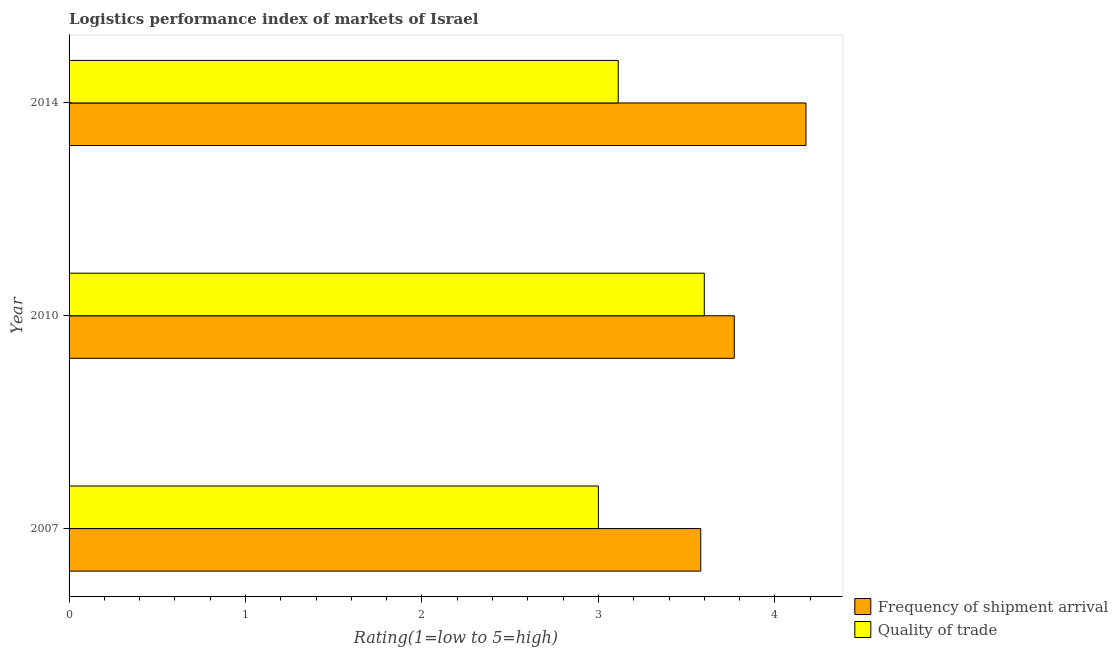How many different coloured bars are there?
Your response must be concise. 2. Are the number of bars per tick equal to the number of legend labels?
Your response must be concise. Yes. Are the number of bars on each tick of the Y-axis equal?
Make the answer very short. Yes. How many bars are there on the 3rd tick from the bottom?
Ensure brevity in your answer.  2. Across all years, what is the minimum lpi of frequency of shipment arrival?
Your answer should be compact. 3.58. In which year was the lpi quality of trade maximum?
Make the answer very short. 2010. What is the total lpi quality of trade in the graph?
Offer a very short reply. 9.71. What is the difference between the lpi of frequency of shipment arrival in 2007 and that in 2014?
Keep it short and to the point. -0.6. What is the difference between the lpi quality of trade in 2010 and the lpi of frequency of shipment arrival in 2007?
Provide a succinct answer. 0.02. What is the average lpi of frequency of shipment arrival per year?
Offer a terse response. 3.84. In the year 2010, what is the difference between the lpi quality of trade and lpi of frequency of shipment arrival?
Ensure brevity in your answer.  -0.17. What is the ratio of the lpi quality of trade in 2010 to that in 2014?
Provide a short and direct response. 1.16. Is the lpi of frequency of shipment arrival in 2007 less than that in 2010?
Your answer should be very brief. Yes. What is the difference between the highest and the second highest lpi of frequency of shipment arrival?
Offer a very short reply. 0.41. In how many years, is the lpi of frequency of shipment arrival greater than the average lpi of frequency of shipment arrival taken over all years?
Your answer should be compact. 1. Is the sum of the lpi of frequency of shipment arrival in 2007 and 2014 greater than the maximum lpi quality of trade across all years?
Ensure brevity in your answer.  Yes. What does the 2nd bar from the top in 2010 represents?
Make the answer very short. Frequency of shipment arrival. What does the 1st bar from the bottom in 2010 represents?
Ensure brevity in your answer.  Frequency of shipment arrival. How many bars are there?
Your answer should be compact. 6. How many years are there in the graph?
Offer a very short reply. 3. What is the difference between two consecutive major ticks on the X-axis?
Give a very brief answer. 1. Are the values on the major ticks of X-axis written in scientific E-notation?
Your response must be concise. No. Does the graph contain grids?
Ensure brevity in your answer.  No. Where does the legend appear in the graph?
Provide a short and direct response. Bottom right. What is the title of the graph?
Offer a terse response. Logistics performance index of markets of Israel. What is the label or title of the X-axis?
Offer a terse response. Rating(1=low to 5=high). What is the label or title of the Y-axis?
Provide a short and direct response. Year. What is the Rating(1=low to 5=high) of Frequency of shipment arrival in 2007?
Ensure brevity in your answer.  3.58. What is the Rating(1=low to 5=high) in Frequency of shipment arrival in 2010?
Keep it short and to the point. 3.77. What is the Rating(1=low to 5=high) of Quality of trade in 2010?
Your answer should be very brief. 3.6. What is the Rating(1=low to 5=high) of Frequency of shipment arrival in 2014?
Provide a short and direct response. 4.18. What is the Rating(1=low to 5=high) of Quality of trade in 2014?
Provide a succinct answer. 3.11. Across all years, what is the maximum Rating(1=low to 5=high) in Frequency of shipment arrival?
Your answer should be very brief. 4.18. Across all years, what is the minimum Rating(1=low to 5=high) in Frequency of shipment arrival?
Provide a succinct answer. 3.58. Across all years, what is the minimum Rating(1=low to 5=high) in Quality of trade?
Ensure brevity in your answer.  3. What is the total Rating(1=low to 5=high) of Frequency of shipment arrival in the graph?
Your answer should be very brief. 11.53. What is the total Rating(1=low to 5=high) of Quality of trade in the graph?
Make the answer very short. 9.71. What is the difference between the Rating(1=low to 5=high) of Frequency of shipment arrival in 2007 and that in 2010?
Your answer should be very brief. -0.19. What is the difference between the Rating(1=low to 5=high) of Frequency of shipment arrival in 2007 and that in 2014?
Ensure brevity in your answer.  -0.6. What is the difference between the Rating(1=low to 5=high) in Quality of trade in 2007 and that in 2014?
Your answer should be compact. -0.11. What is the difference between the Rating(1=low to 5=high) of Frequency of shipment arrival in 2010 and that in 2014?
Keep it short and to the point. -0.41. What is the difference between the Rating(1=low to 5=high) of Quality of trade in 2010 and that in 2014?
Make the answer very short. 0.49. What is the difference between the Rating(1=low to 5=high) in Frequency of shipment arrival in 2007 and the Rating(1=low to 5=high) in Quality of trade in 2010?
Provide a short and direct response. -0.02. What is the difference between the Rating(1=low to 5=high) of Frequency of shipment arrival in 2007 and the Rating(1=low to 5=high) of Quality of trade in 2014?
Offer a very short reply. 0.47. What is the difference between the Rating(1=low to 5=high) of Frequency of shipment arrival in 2010 and the Rating(1=low to 5=high) of Quality of trade in 2014?
Ensure brevity in your answer.  0.66. What is the average Rating(1=low to 5=high) of Frequency of shipment arrival per year?
Provide a succinct answer. 3.84. What is the average Rating(1=low to 5=high) of Quality of trade per year?
Keep it short and to the point. 3.24. In the year 2007, what is the difference between the Rating(1=low to 5=high) in Frequency of shipment arrival and Rating(1=low to 5=high) in Quality of trade?
Make the answer very short. 0.58. In the year 2010, what is the difference between the Rating(1=low to 5=high) in Frequency of shipment arrival and Rating(1=low to 5=high) in Quality of trade?
Offer a terse response. 0.17. In the year 2014, what is the difference between the Rating(1=low to 5=high) of Frequency of shipment arrival and Rating(1=low to 5=high) of Quality of trade?
Give a very brief answer. 1.06. What is the ratio of the Rating(1=low to 5=high) of Frequency of shipment arrival in 2007 to that in 2010?
Offer a terse response. 0.95. What is the ratio of the Rating(1=low to 5=high) of Quality of trade in 2007 to that in 2010?
Your response must be concise. 0.83. What is the ratio of the Rating(1=low to 5=high) in Frequency of shipment arrival in 2007 to that in 2014?
Provide a succinct answer. 0.86. What is the ratio of the Rating(1=low to 5=high) of Quality of trade in 2007 to that in 2014?
Your answer should be very brief. 0.96. What is the ratio of the Rating(1=low to 5=high) in Frequency of shipment arrival in 2010 to that in 2014?
Provide a succinct answer. 0.9. What is the ratio of the Rating(1=low to 5=high) in Quality of trade in 2010 to that in 2014?
Provide a succinct answer. 1.16. What is the difference between the highest and the second highest Rating(1=low to 5=high) of Frequency of shipment arrival?
Keep it short and to the point. 0.41. What is the difference between the highest and the second highest Rating(1=low to 5=high) in Quality of trade?
Ensure brevity in your answer.  0.49. What is the difference between the highest and the lowest Rating(1=low to 5=high) of Frequency of shipment arrival?
Ensure brevity in your answer.  0.6. What is the difference between the highest and the lowest Rating(1=low to 5=high) of Quality of trade?
Keep it short and to the point. 0.6. 